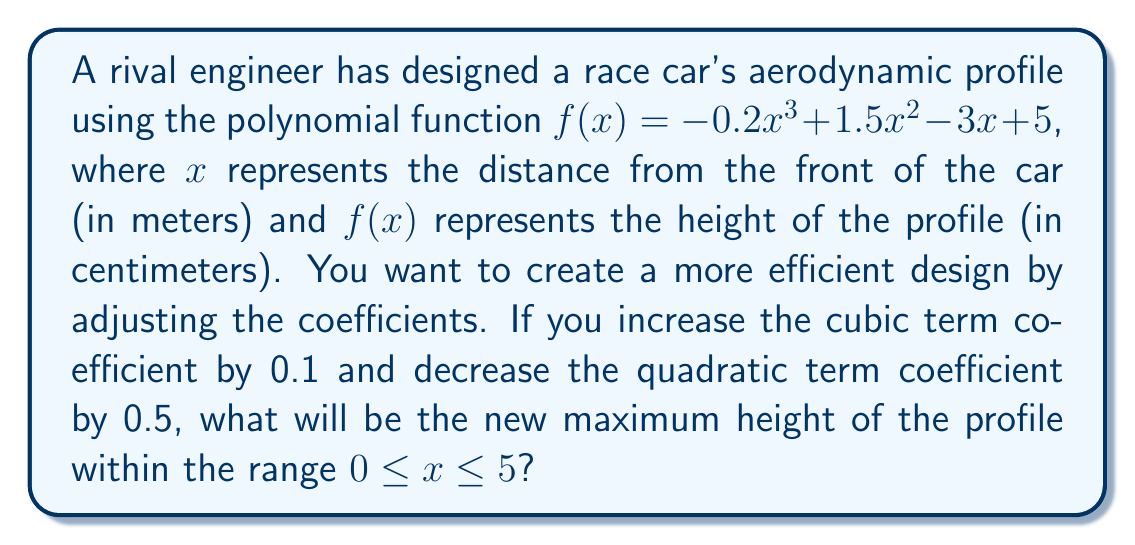Help me with this question. To solve this problem, we'll follow these steps:

1) First, let's write the new polynomial function:
   $g(x) = (-0.2 + 0.1)x^3 + (1.5 - 0.5)x^2 - 3x + 5$
   $g(x) = -0.1x^3 + x^2 - 3x + 5$

2) To find the maximum height, we need to find the critical points of $g(x)$ by taking its derivative and setting it to zero:
   $g'(x) = -0.3x^2 + 2x - 3$

3) Set $g'(x) = 0$:
   $-0.3x^2 + 2x - 3 = 0$

4) This is a quadratic equation. We can solve it using the quadratic formula:
   $x = \frac{-b \pm \sqrt{b^2 - 4ac}}{2a}$

   Where $a = -0.3$, $b = 2$, and $c = -3$

5) Plugging in these values:
   $x = \frac{-2 \pm \sqrt{4 - 4(-0.3)(-3)}}{2(-0.3)}$
   $x = \frac{-2 \pm \sqrt{4 - 3.6}}{-0.6}$
   $x = \frac{-2 \pm \sqrt{0.4}}{-0.6}$
   $x = \frac{-2 \pm 0.632}{-0.6}$

6) This gives us two critical points:
   $x_1 = \frac{-2 + 0.632}{-0.6} \approx 2.28$
   $x_2 = \frac{-2 - 0.632}{-0.6} \approx 4.39$

7) We also need to check the endpoints of our range, $x = 0$ and $x = 5$

8) Now, let's evaluate $g(x)$ at these four points:
   $g(0) = 5$
   $g(2.28) \approx 6.77$
   $g(4.39) \approx 3.62$
   $g(5) = 2.5$

9) The maximum value among these is approximately 6.77, which occurs at $x \approx 2.28$

Therefore, the new maximum height of the profile is approximately 6.77 cm.
Answer: 6.77 cm 